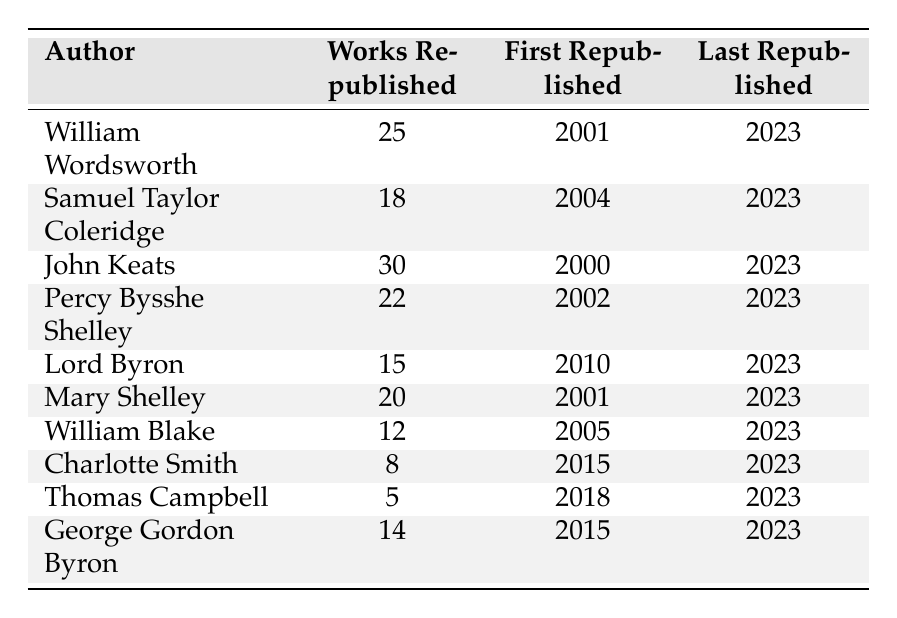What is the total number of works republished by John Keats? The table states that John Keats has 30 works republished.
Answer: 30 Which author has the least number of works republished? The table indicates that Thomas Campbell has the least republished works with a total of 5.
Answer: 5 How many authors have more than 20 works republished? Two authors, John Keats (30) and Percy Bysshe Shelley (22), have more than 20 works republished.
Answer: 2 What year was the first work of William Blake republished? According to the table, William Blake's works were first republished in 2005.
Answer: 2005 Is it true that Mary Shelley has more works republished than Lord Byron? Yes, Mary Shelley has 20 works republished while Lord Byron has only 15, which confirms the statement.
Answer: Yes What is the average number of works republished by all the authors listed? The total number of works republished is 25 + 18 + 30 + 22 + 15 + 20 + 12 + 8 + 5 + 14 =  169. There are 10 authors, so the average is 169 / 10 = 16.9.
Answer: 16.9 What is the range of the years in which works were republished for Samuel Taylor Coleridge? Samuel Taylor Coleridge's works were first republished in 2004 and last republished in 2023, giving a range of 2023 - 2004 = 19 years.
Answer: 19 years Which author has the highest number of works republished between 2000 and 2005? John Keats has the highest number with 30 works republished, which is more than any other author in that time frame listed.
Answer: 30 How many total works were republished by both William Wordsworth and Mary Shelley combined? William Wordsworth has 25 works and Mary Shelley has 20 works. Together they have 25 + 20 = 45 works republished.
Answer: 45 Which authors first published their works in 2001? Both William Wordsworth and Mary Shelley had their works first republished in 2001, as noted in the table.
Answer: William Wordsworth and Mary Shelley What is the difference in the number of works republished between Charlotte Smith and George Gordon Byron? Charlotte Smith has 8 works while George Gordon Byron has 14, so the difference is 14 - 8 = 6.
Answer: 6 